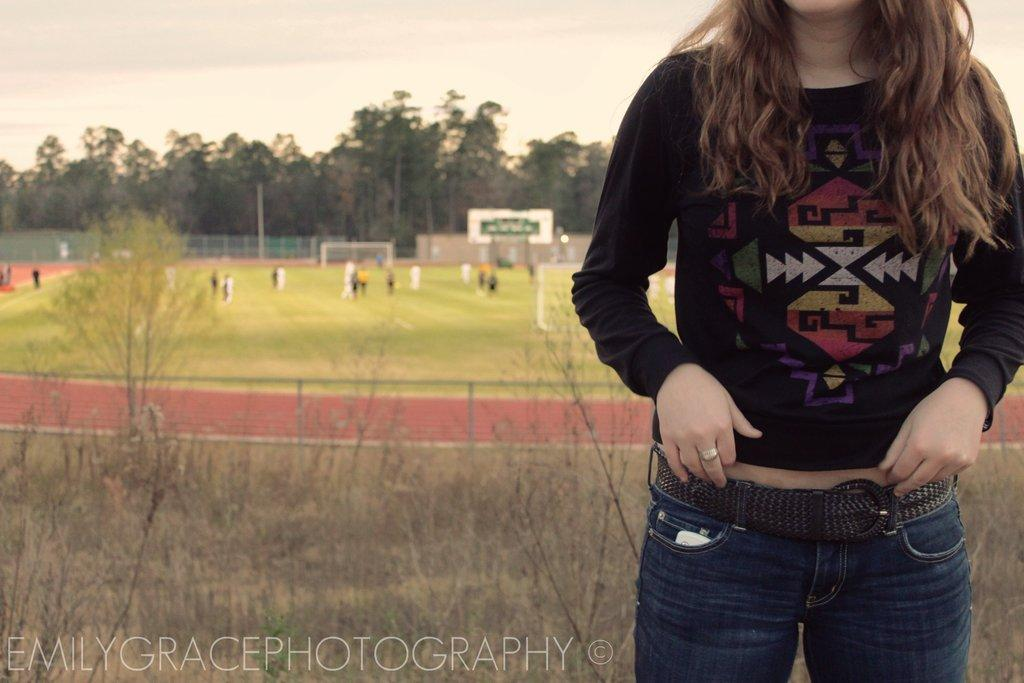What is the woman in the image doing? The woman is standing on the ground. What can be seen in the background of the image? There is a sports ground, persons standing on the ground, trees, a fence, and the sky with clouds in the background. How many elements can be identified in the background? There are six elements in the background: a sports ground, persons standing on the ground, trees, a fence, and the sky with clouds. What type of vegetation is visible in the background? Trees are visible in the background. What type of holiday is the woman celebrating in the image? There is no indication of a holiday in the image; it simply shows a woman standing on the ground with a background containing various elements. Are there any police officers visible in the image? There are no police officers present in the image. 